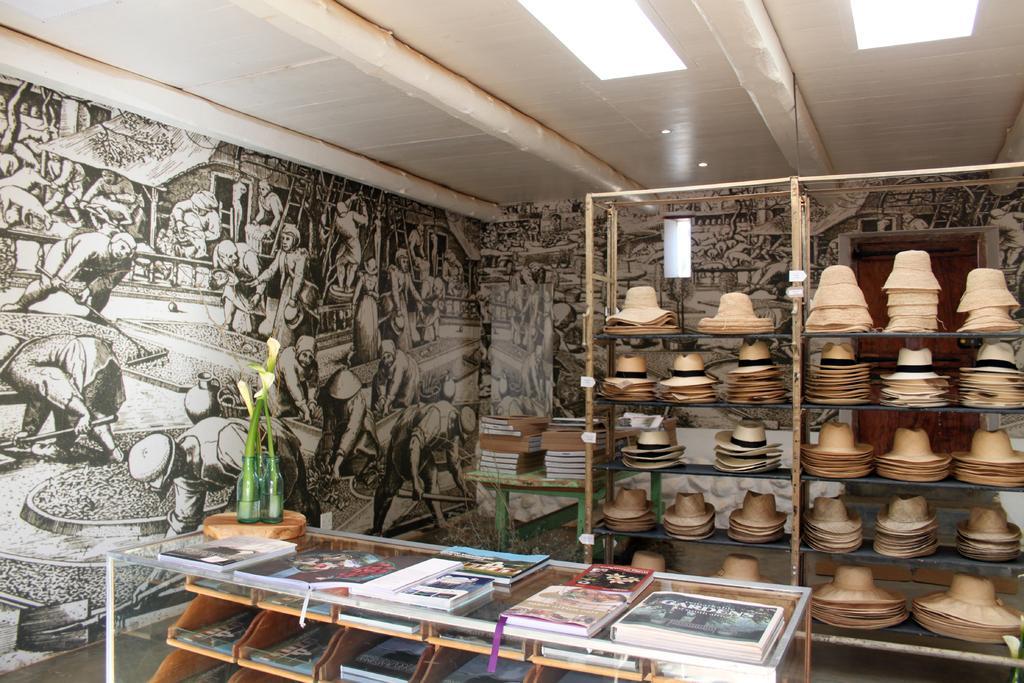In one or two sentences, can you explain what this image depicts? In this image in the front there is a table and on the table there are books and there is a plant. In the center there is a shelf and on the shelf there are hats and in the background there is painting on the wall and there is a door. 